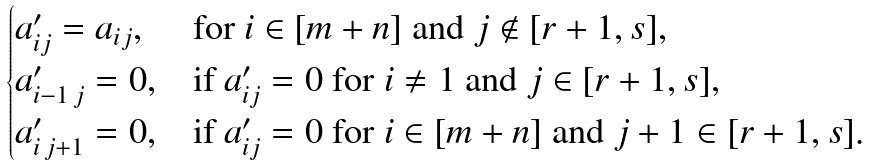Convert formula to latex. <formula><loc_0><loc_0><loc_500><loc_500>\begin{cases} a ^ { \prime } _ { i j } = a _ { i j } , & \text {for $i\in [m+n]$ and $j\not\in [r+1,s]$} , \\ a ^ { \prime } _ { i - 1 \, j } = 0 , & \text {if $a^{\prime}_{ij}=0$ for $i\neq 1$ and $j\in [r+1,s]$} , \\ a ^ { \prime } _ { i \, j + 1 } = 0 , & \text {if $a^{\prime}_{ij}=0$ for $i\in [m+n]$ and $j+1\in [r+1,s]$} . \end{cases}</formula> 